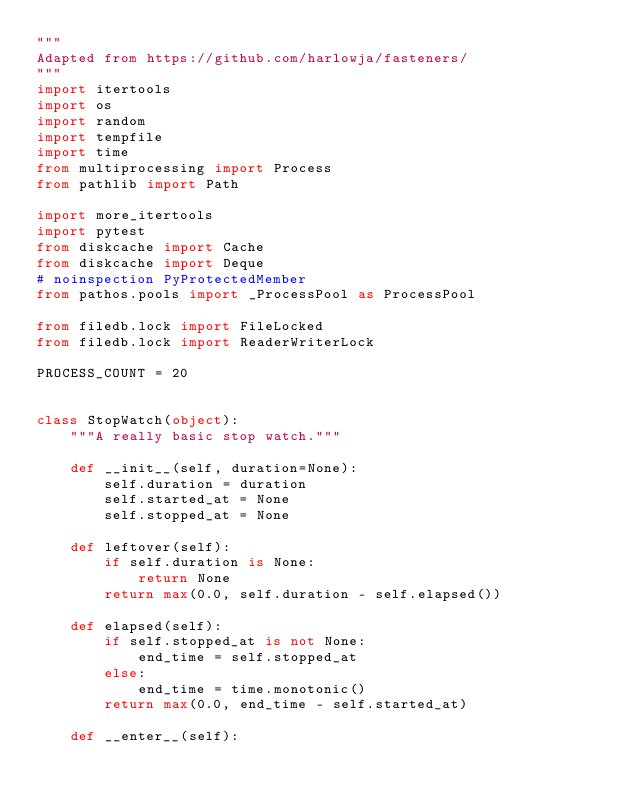<code> <loc_0><loc_0><loc_500><loc_500><_Python_>"""
Adapted from https://github.com/harlowja/fasteners/
"""
import itertools
import os
import random
import tempfile
import time
from multiprocessing import Process
from pathlib import Path

import more_itertools
import pytest
from diskcache import Cache
from diskcache import Deque
# noinspection PyProtectedMember
from pathos.pools import _ProcessPool as ProcessPool

from filedb.lock import FileLocked
from filedb.lock import ReaderWriterLock

PROCESS_COUNT = 20


class StopWatch(object):
    """A really basic stop watch."""

    def __init__(self, duration=None):
        self.duration = duration
        self.started_at = None
        self.stopped_at = None

    def leftover(self):
        if self.duration is None:
            return None
        return max(0.0, self.duration - self.elapsed())

    def elapsed(self):
        if self.stopped_at is not None:
            end_time = self.stopped_at
        else:
            end_time = time.monotonic()
        return max(0.0, end_time - self.started_at)

    def __enter__(self):</code> 